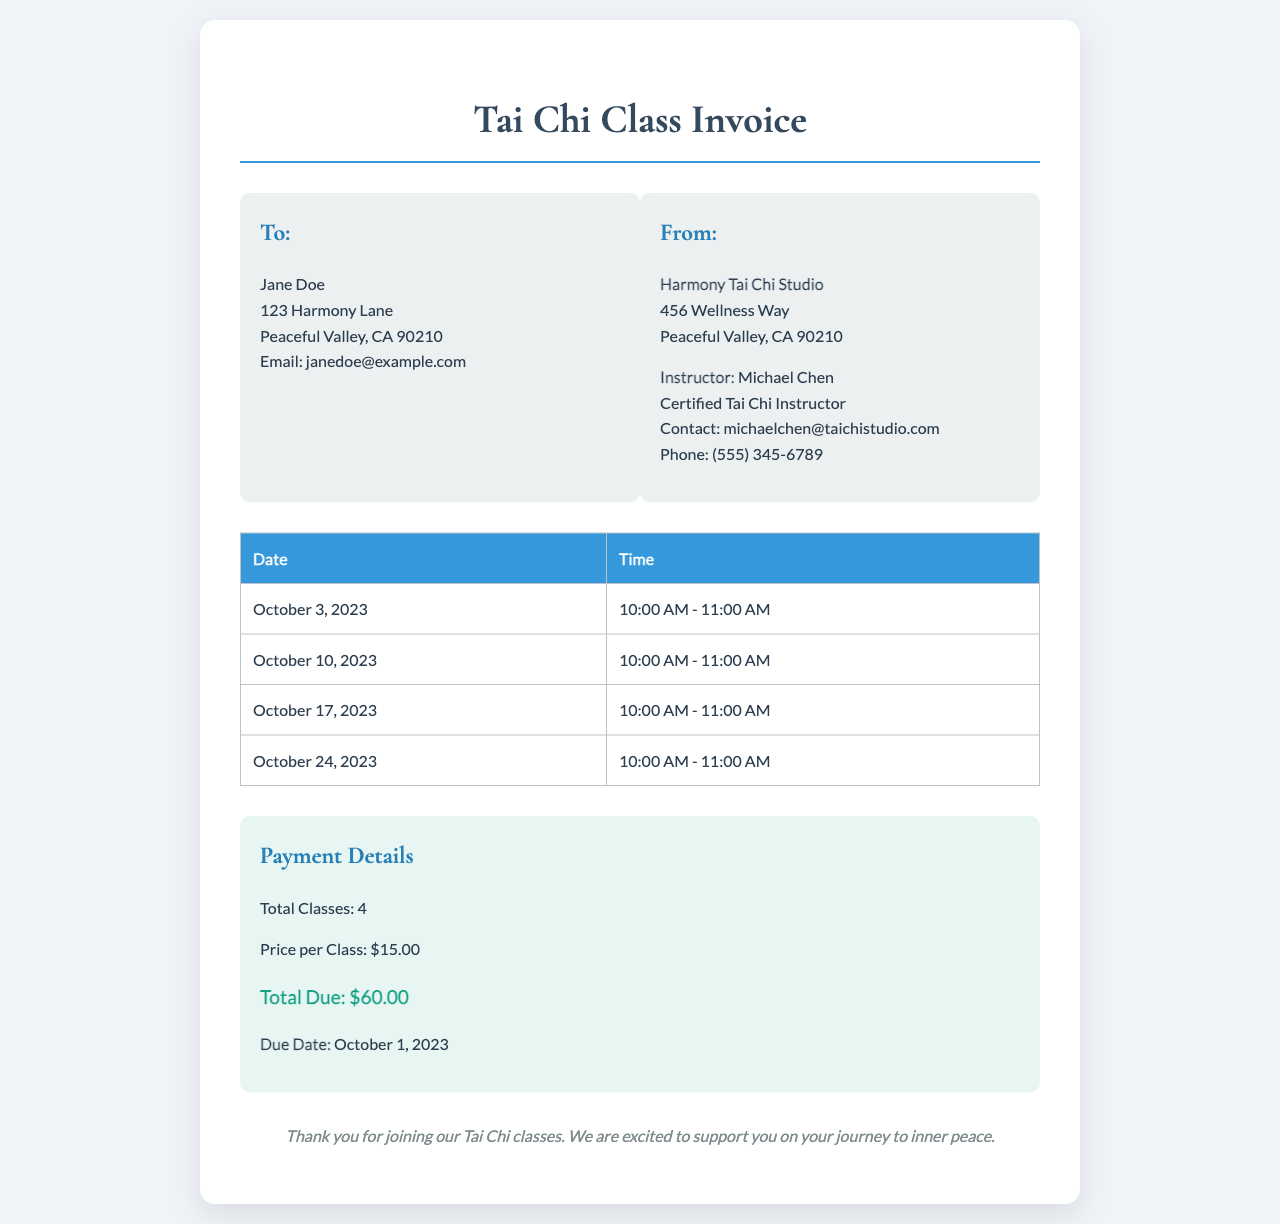What is the name of the student? The student's name is listed in the "To" section of the invoice as Jane Doe.
Answer: Jane Doe What is the instructor's name? The instructor's name is provided in the "From" section of the invoice.
Answer: Michael Chen How many classes are included in the invoice? The total number of classes is stated in the payment section of the invoice.
Answer: 4 What is the total amount due for the classes? The total due is calculated and specified in the payment section.
Answer: $60.00 When is the due date for the payment? The due date for the payment is explicitly mentioned in the payment section.
Answer: October 1, 2023 What is the price per class? The price for each individual class is outlined in the payment details.
Answer: $15.00 What is the location of the Tai Chi studio? The address of the Tai Chi Studio is found in the "From" section of the invoice.
Answer: 456 Wellness Way What day is the first class scheduled? The date of the first class is listed in the classes table.
Answer: October 3, 2023 Who can be contacted for more information about the classes? The invoice provides a contact email for the instructor in the "From" section.
Answer: michaelchen@taichistudio.com 